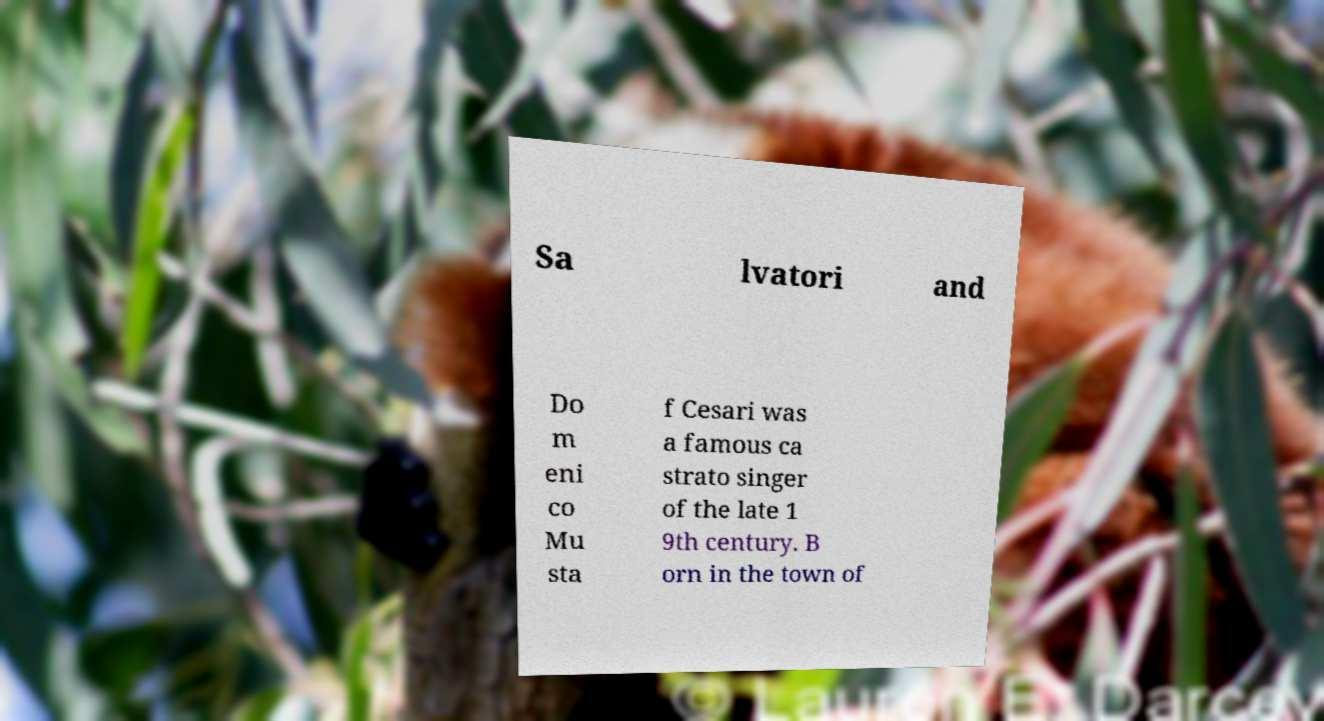For documentation purposes, I need the text within this image transcribed. Could you provide that? Sa lvatori and Do m eni co Mu sta f Cesari was a famous ca strato singer of the late 1 9th century. B orn in the town of 